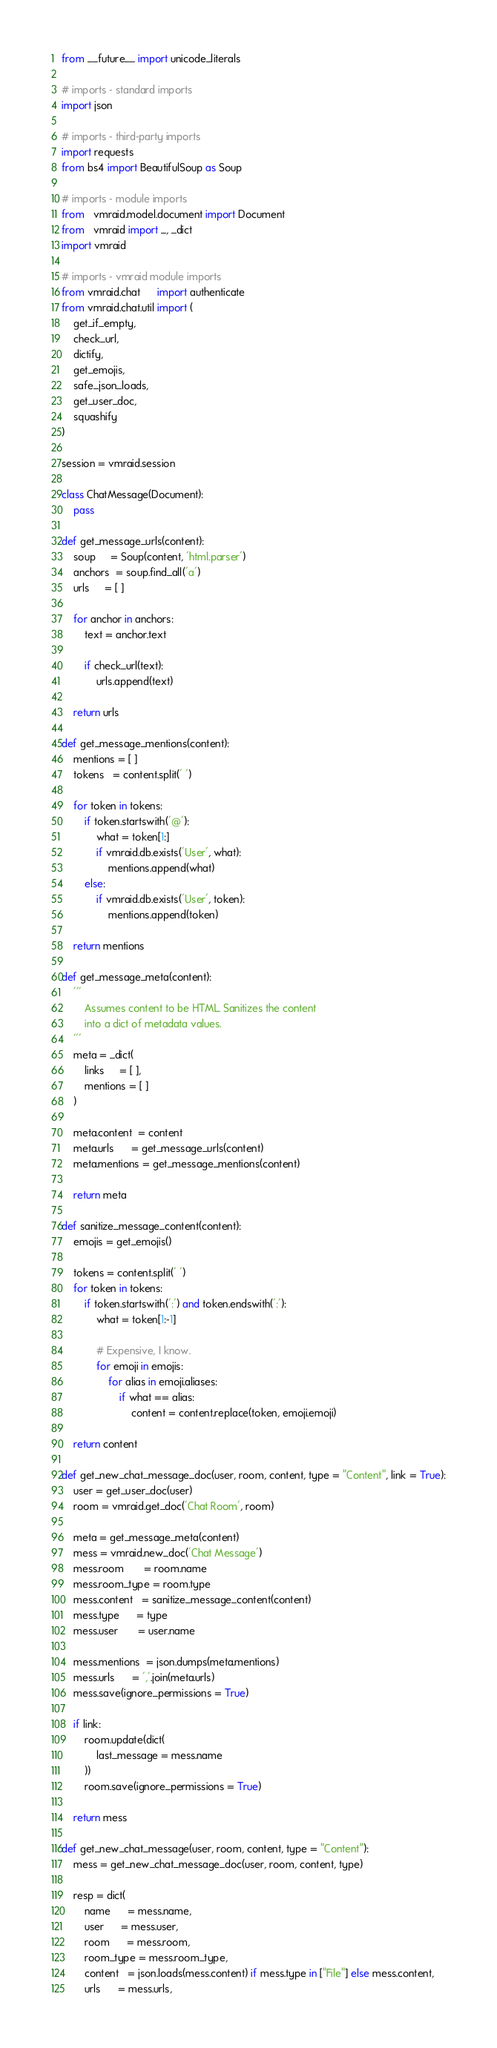<code> <loc_0><loc_0><loc_500><loc_500><_Python_>from __future__ import unicode_literals

# imports - standard imports
import json

# imports - third-party imports
import requests
from bs4 import BeautifulSoup as Soup

# imports - module imports
from   vmraid.model.document import Document
from   vmraid import _, _dict
import vmraid

# imports - vmraid module imports
from vmraid.chat 	  import authenticate
from vmraid.chat.util import (
	get_if_empty,
	check_url,
	dictify,
	get_emojis,
	safe_json_loads,
	get_user_doc,
	squashify
)

session = vmraid.session

class ChatMessage(Document):
	pass

def get_message_urls(content):
	soup     = Soup(content, 'html.parser')
	anchors  = soup.find_all('a')
	urls     = [ ]

	for anchor in anchors:
		text = anchor.text

		if check_url(text):
			urls.append(text)

	return urls

def get_message_mentions(content):
	mentions = [ ]
	tokens   = content.split(' ')

	for token in tokens:
		if token.startswith('@'):
			what = token[1:]
			if vmraid.db.exists('User', what):
				mentions.append(what)
		else:
			if vmraid.db.exists('User', token):
				mentions.append(token)

	return mentions

def get_message_meta(content):
	'''
		Assumes content to be HTML. Sanitizes the content
		into a dict of metadata values.
	'''
	meta = _dict(
		links 	 = [ ],
		mentions = [ ]
	)

	meta.content  = content
	meta.urls	  = get_message_urls(content)
	meta.mentions = get_message_mentions(content)

	return meta

def sanitize_message_content(content):
	emojis = get_emojis()

	tokens = content.split(' ')
	for token in tokens:
		if token.startswith(':') and token.endswith(':'):
			what = token[1:-1]

			# Expensive, I know.
			for emoji in emojis:
				for alias in emoji.aliases:
					if what == alias:
						content = content.replace(token, emoji.emoji)

	return content

def get_new_chat_message_doc(user, room, content, type = "Content", link = True):
	user = get_user_doc(user)
	room = vmraid.get_doc('Chat Room', room)

	meta = get_message_meta(content)
	mess = vmraid.new_doc('Chat Message')
	mess.room 	   = room.name
	mess.room_type = room.type
	mess.content   = sanitize_message_content(content)
	mess.type      = type
	mess.user	   = user.name

	mess.mentions  = json.dumps(meta.mentions)
	mess.urls      = ','.join(meta.urls)
	mess.save(ignore_permissions = True)

	if link:
		room.update(dict(
			last_message = mess.name
		))
		room.save(ignore_permissions = True)

	return mess

def get_new_chat_message(user, room, content, type = "Content"):
	mess = get_new_chat_message_doc(user, room, content, type)

	resp = dict(
		name      = mess.name,
		user      = mess.user,
		room      = mess.room,
		room_type = mess.room_type,
		content   = json.loads(mess.content) if mess.type in ["File"] else mess.content,
		urls      = mess.urls,</code> 